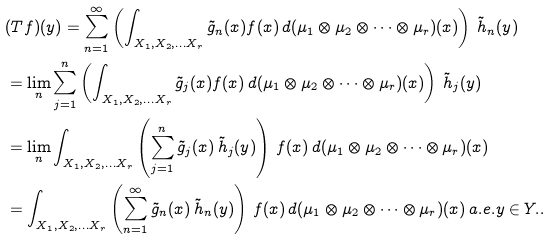<formula> <loc_0><loc_0><loc_500><loc_500>& ( T f ) ( y ) = \sum _ { n = 1 } ^ { \infty } \left ( \int _ { X _ { 1 } , X _ { 2 } , \dots X _ { r } } \tilde { g } _ { n } ( x ) f ( x ) \, d ( \mu _ { 1 } \otimes \mu _ { 2 } \otimes \cdots \otimes \mu _ { r } ) ( x ) \right ) \, \tilde { h } _ { n } ( y ) \\ & = \lim _ { n } \sum _ { j = 1 } ^ { n } \left ( \int _ { X _ { 1 } , X _ { 2 } , \dots X _ { r } } \tilde { g } _ { j } ( x ) f ( x ) \, d ( \mu _ { 1 } \otimes \mu _ { 2 } \otimes \cdots \otimes \mu _ { r } ) ( x ) \right ) \, \tilde { h } _ { j } ( y ) \\ & = \lim _ { n } \int _ { X _ { 1 } , X _ { 2 } , \dots X _ { r } } \left ( \sum _ { j = 1 } ^ { n } \tilde { g } _ { j } ( x ) \, \tilde { h } _ { j } ( y ) \right ) \, f ( x ) \, d ( \mu _ { 1 } \otimes \mu _ { 2 } \otimes \cdots \otimes \mu _ { r } ) ( x ) \\ & = \int _ { X _ { 1 } , X _ { 2 } , \dots X _ { r } } \left ( \sum _ { n = 1 } ^ { \infty } \tilde { g } _ { n } ( x ) \, \tilde { h } _ { n } ( y ) \right ) \, f ( x ) \, d ( \mu _ { 1 } \otimes \mu _ { 2 } \otimes \cdots \otimes \mu _ { r } ) ( x ) \, a . e . y \in Y . .</formula> 